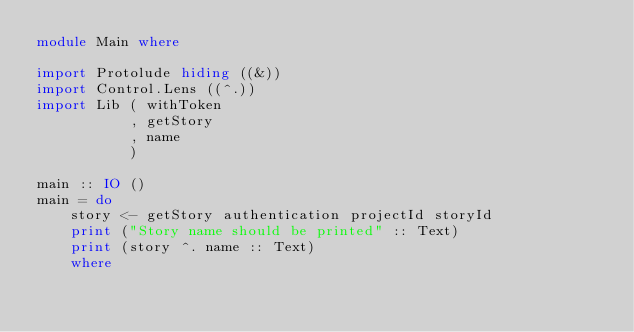<code> <loc_0><loc_0><loc_500><loc_500><_Haskell_>module Main where

import Protolude hiding ((&))
import Control.Lens ((^.))
import Lib ( withToken
           , getStory
           , name
           )

main :: IO ()
main = do
    story <- getStory authentication projectId storyId
    print ("Story name should be printed" :: Text)
    print (story ^. name :: Text)
    where</code> 